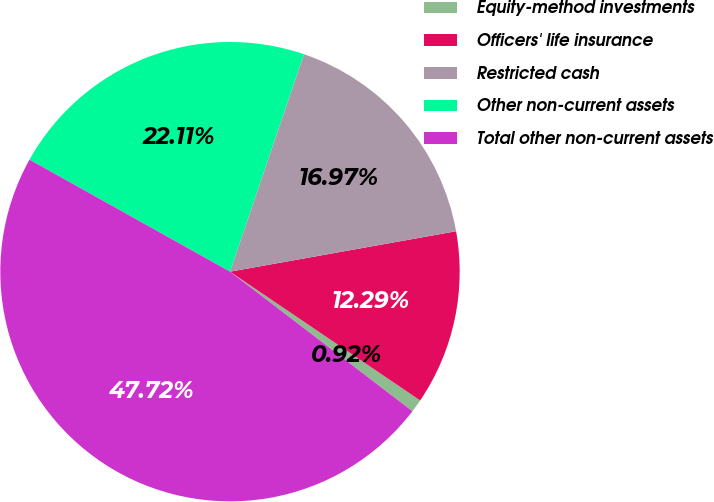<chart> <loc_0><loc_0><loc_500><loc_500><pie_chart><fcel>Equity-method investments<fcel>Officers' life insurance<fcel>Restricted cash<fcel>Other non-current assets<fcel>Total other non-current assets<nl><fcel>0.92%<fcel>12.29%<fcel>16.97%<fcel>22.11%<fcel>47.72%<nl></chart> 